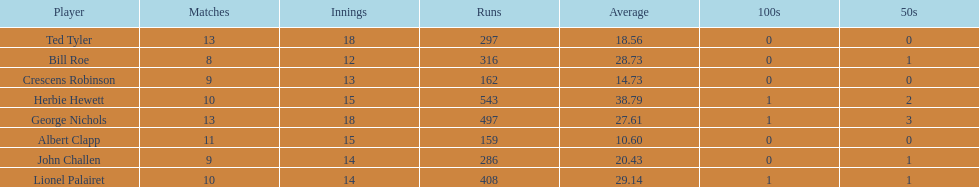Name a player whose average was above 25. Herbie Hewett. Could you help me parse every detail presented in this table? {'header': ['Player', 'Matches', 'Innings', 'Runs', 'Average', '100s', '50s'], 'rows': [['Ted Tyler', '13', '18', '297', '18.56', '0', '0'], ['Bill Roe', '8', '12', '316', '28.73', '0', '1'], ['Crescens Robinson', '9', '13', '162', '14.73', '0', '0'], ['Herbie Hewett', '10', '15', '543', '38.79', '1', '2'], ['George Nichols', '13', '18', '497', '27.61', '1', '3'], ['Albert Clapp', '11', '15', '159', '10.60', '0', '0'], ['John Challen', '9', '14', '286', '20.43', '0', '1'], ['Lionel Palairet', '10', '14', '408', '29.14', '1', '1']]} 